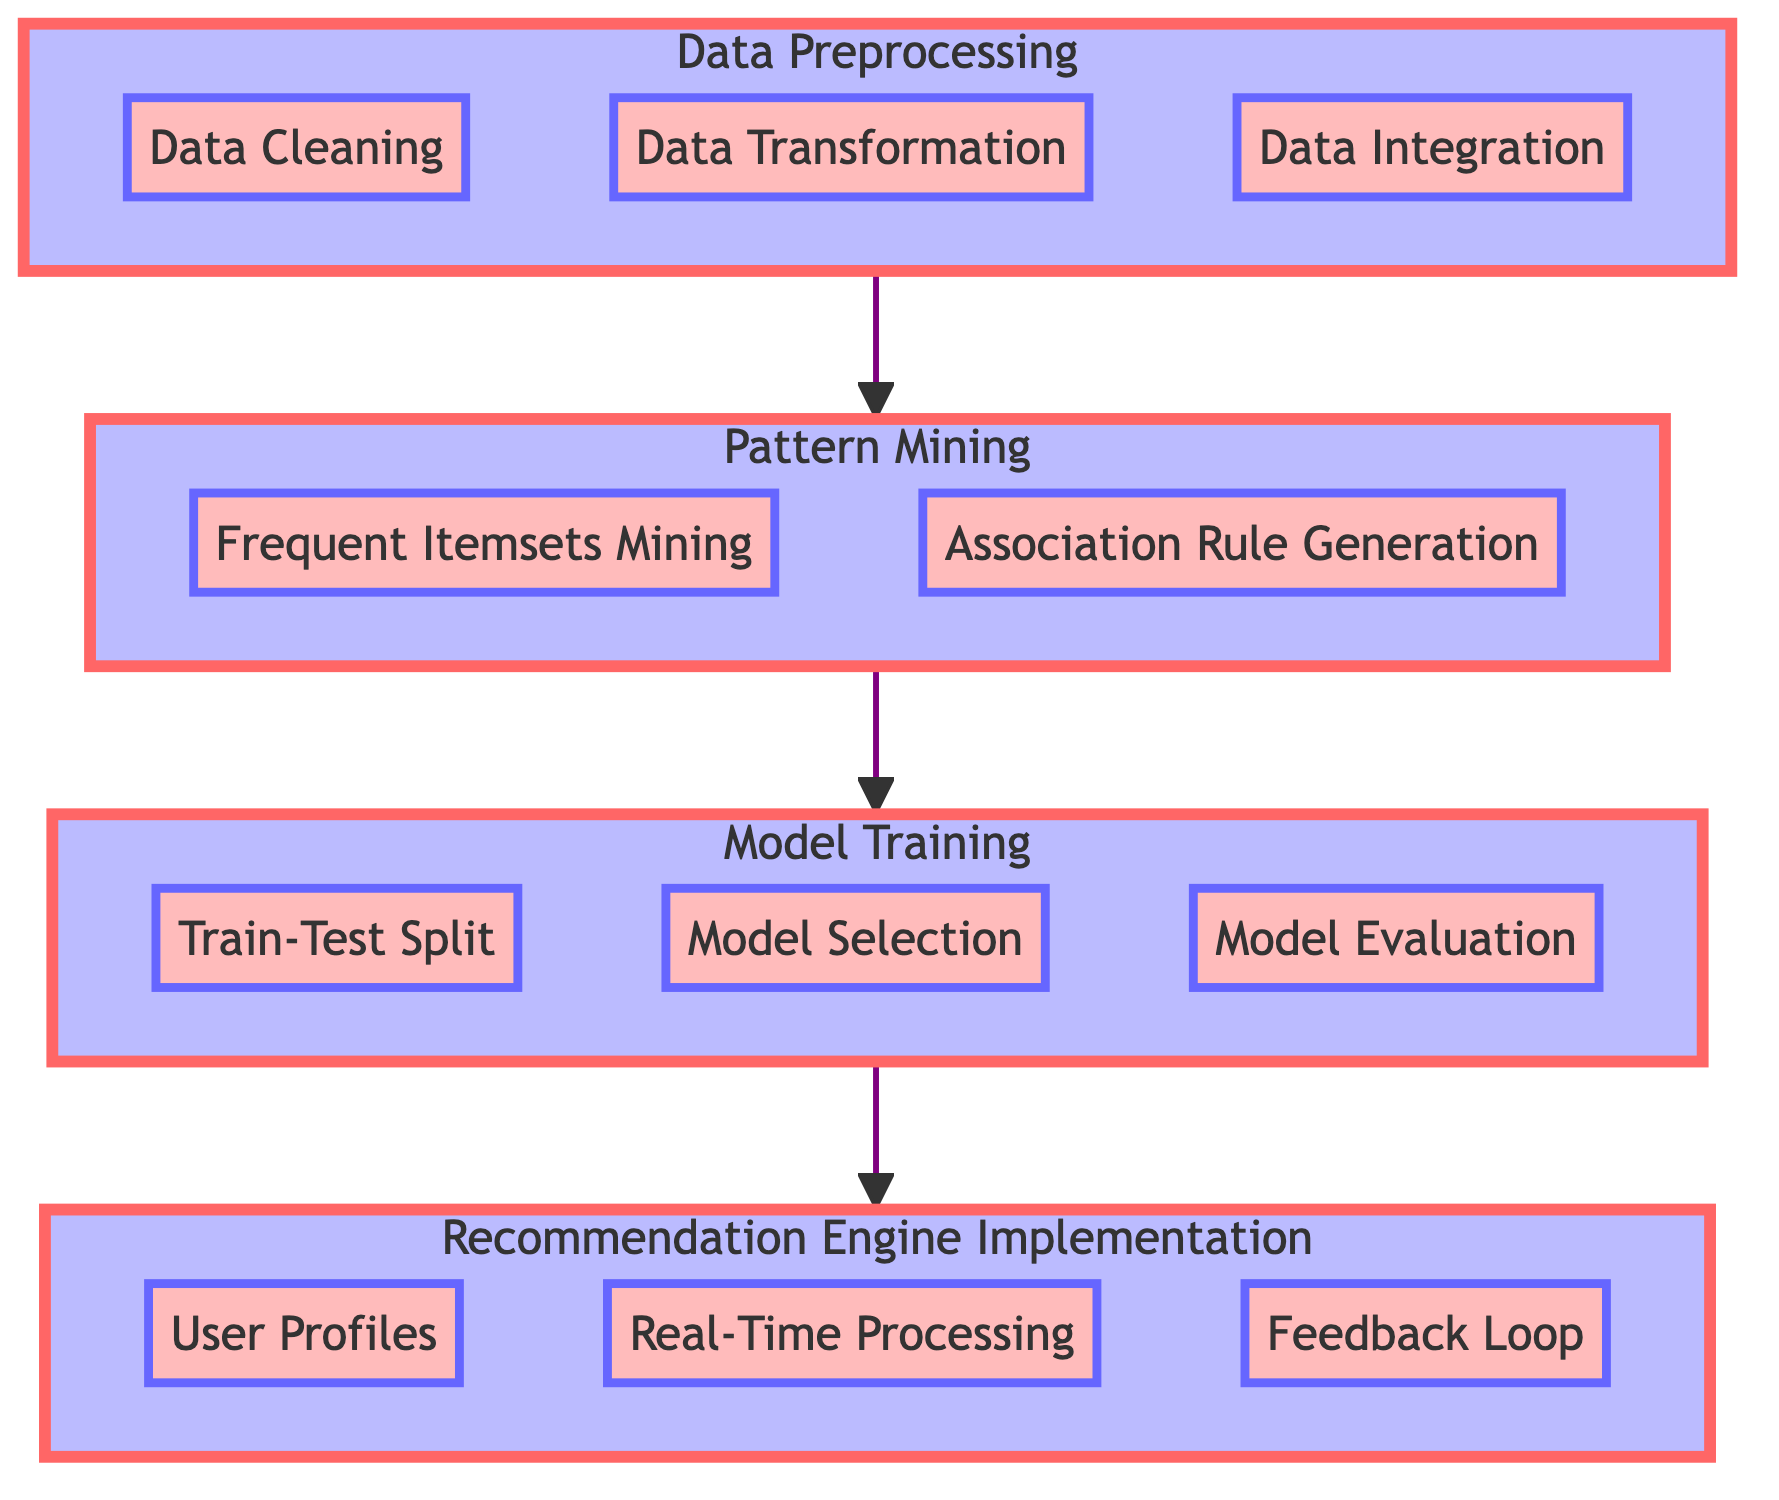What is the first step in the workflow? The diagram indicates that the first step in the workflow is Data Preprocessing, as it is the bottommost node and the starting point of the depicted process.
Answer: Data Preprocessing How many sub-elements are in the Model Training section? Within the Model Training section, there are three sub-elements: Train-Test Split, Model Selection, and Model Evaluation, which can be counted from the diagram.
Answer: Three What comes after Pattern Mining in the workflow? According to the flow chart, the sequence shows that Model Training directly follows Pattern Mining, as indicated by the directed arrow connecting the two sections.
Answer: Model Training Which node is directly connected to Recommendation Engine? The Recommendation Engine node is directly preceded by the Model Training node in the workflow, as illustrated by the upward flow of the arrows in the chart.
Answer: Model Training What are the three sub-elements of Recommendation Engine Implementation? The diagram lists three sub-elements under the Recommendation Engine section: User Profiles, Real-Time Processing, and Feedback Loop, which can be easily identified in the chart.
Answer: User Profiles, Real-Time Processing, Feedback Loop Which part of the workflow links Data Cleaning and Data Transformation? The Data Preprocessing section, which consists of both Data Cleaning and Data Transformation as its sub-elements, serves as the link between them as they are both part of the same group connected by the preceding arrow.
Answer: Data Preprocessing If you proceed from Data Integration, what is the next section? From the Data Integration node, the next section is Pattern Mining, as indicated by the upward arrow that leads from Data Preprocessing to Pattern Mining.
Answer: Pattern Mining What are the two main activities in Pattern Mining? The diagram specifies that the two main activities in the Pattern Mining section are Frequent Itemsets Mining and Association Rule Generation, clearly shown as sub-elements of that section.
Answer: Frequent Itemsets Mining, Association Rule Generation What type of questions will the feedback loop address after recommendations are provided? The feedback loop will address user feedback, which includes positive and negative feedback that can improve future recommendations, as indicated in the outskirts of the Recommendation Engine Implementation section.
Answer: User feedback 